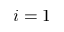<formula> <loc_0><loc_0><loc_500><loc_500>i = 1</formula> 